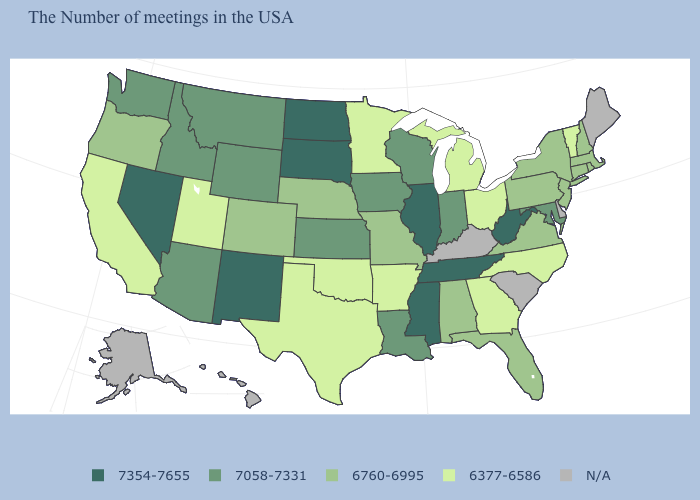What is the lowest value in the West?
Write a very short answer. 6377-6586. What is the value of New York?
Answer briefly. 6760-6995. Among the states that border California , does Oregon have the highest value?
Be succinct. No. Name the states that have a value in the range N/A?
Concise answer only. Maine, Delaware, South Carolina, Kentucky, Alaska, Hawaii. Does Kansas have the highest value in the MidWest?
Give a very brief answer. No. Is the legend a continuous bar?
Write a very short answer. No. What is the highest value in the MidWest ?
Short answer required. 7354-7655. Which states have the highest value in the USA?
Short answer required. West Virginia, Tennessee, Illinois, Mississippi, South Dakota, North Dakota, New Mexico, Nevada. Name the states that have a value in the range 6760-6995?
Answer briefly. Massachusetts, Rhode Island, New Hampshire, Connecticut, New York, New Jersey, Pennsylvania, Virginia, Florida, Alabama, Missouri, Nebraska, Colorado, Oregon. Which states have the lowest value in the West?
Answer briefly. Utah, California. What is the highest value in the Northeast ?
Write a very short answer. 6760-6995. 